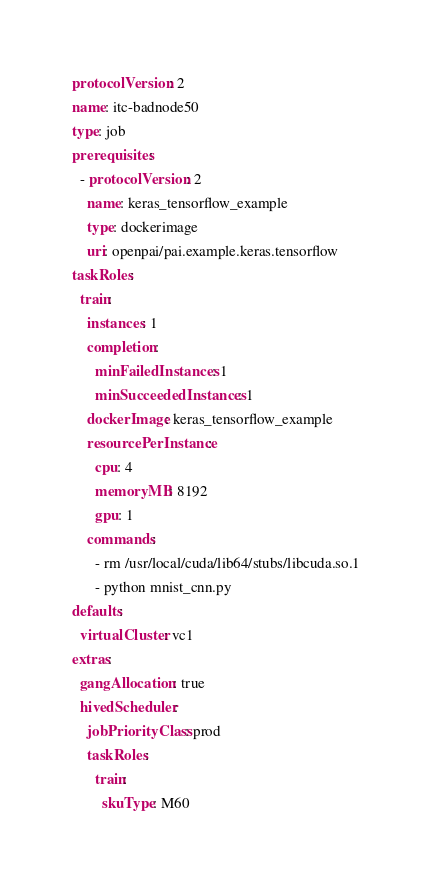<code> <loc_0><loc_0><loc_500><loc_500><_YAML_>protocolVersion: 2
name: itc-badnode50
type: job
prerequisites:
  - protocolVersion: 2
    name: keras_tensorflow_example
    type: dockerimage
    uri: openpai/pai.example.keras.tensorflow
taskRoles:
  train:
    instances: 1
    completion:
      minFailedInstances: 1
      minSucceededInstances: 1
    dockerImage: keras_tensorflow_example
    resourcePerInstance:
      cpu: 4
      memoryMB: 8192
      gpu: 1
    commands:
      - rm /usr/local/cuda/lib64/stubs/libcuda.so.1
      - python mnist_cnn.py
defaults:
  virtualCluster: vc1
extras:
  gangAllocation: true
  hivedScheduler:
    jobPriorityClass: prod
    taskRoles:
      train:
        skuType: M60
</code> 